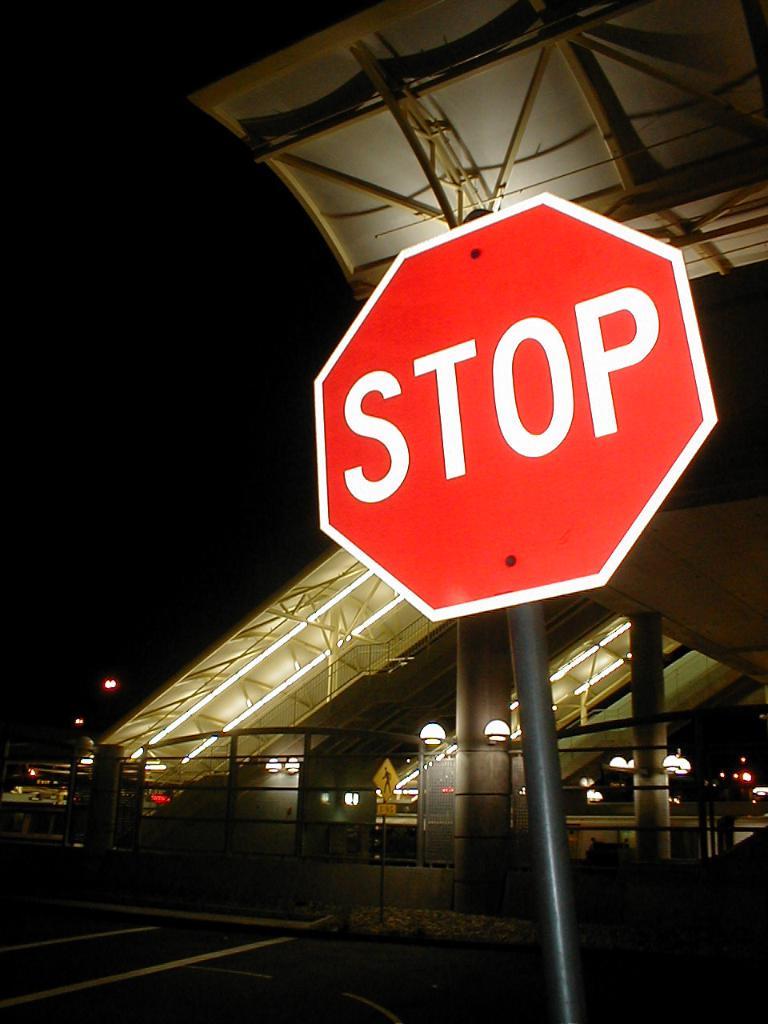What kind of sign is this?
Provide a short and direct response. Stop. 